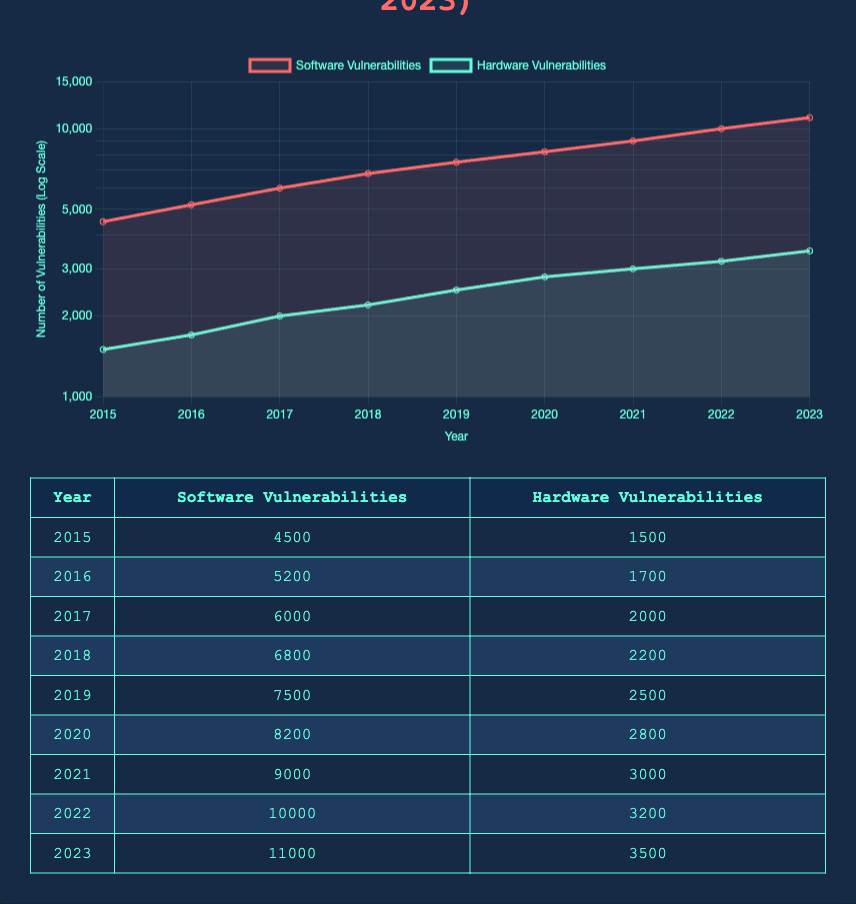What year had the highest number of software vulnerabilities disclosed? By reviewing the table, I see that the number of software vulnerabilities disclosed increases each year, reaching its peak in 2023 with 11000 disclosures.
Answer: 2023 How many hardware vulnerabilities were disclosed in 2019? The table shows that in the year 2019, there were 2500 hardware vulnerabilities disclosed.
Answer: 2500 What is the total number of software vulnerabilities disclosed from 2015 to 2018? To find the total, I add the software vulnerabilities disclosed for each year from 2015 (4500), 2016 (5200), 2017 (6000), and 2018 (6800): 4500 + 5200 + 6000 + 6800 = 22500.
Answer: 22500 Did the number of hardware vulnerabilities disclosed ever decrease during the years 2015 to 2023? I can confirm by looking at the table that the number of hardware vulnerabilities disclosed has consistently increased each year from 2015 (1500) to 2023 (3500), thus there was never a decrease.
Answer: No What is the average number of hardware vulnerabilities disclosed per year from 2020 to 2023? I will add the hardware vulnerabilities disclosed for each year from 2020 (2800), 2021 (3000), 2022 (3200), and 2023 (3500): 2800 + 3000 + 3200 + 3500 = 12500. There are 4 years, so I divide 12500 by 4 to get the average: 12500 / 4 = 3125.
Answer: 3125 Which year showed the largest increase in software vulnerabilities from the previous year? I will calculate the difference in the number of software vulnerabilities disclosed from one year to the next: 2015 to 2016 (5200 - 4500 = 700), 2016 to 2017 (6000 - 5200 = 800), and so on. The largest increase is from 2021 to 2022 (10000 - 9000 = 1000).
Answer: 2021 to 2022 What was the total number of vulnerabilities (both software and hardware) disclosed in 2021? From the table, I see that in 2021, there were 9000 software vulnerabilities and 3000 hardware vulnerabilities disclosed. Adding these together gives 9000 + 3000 = 12000 total vulnerabilities.
Answer: 12000 In how many years were more than 2000 hardware vulnerabilities disclosed? By examining the table, I can see that hardware vulnerabilities were above 2000 every year from 2017 to 2023, which totals to 7 years: 2017, 2018, 2019, 2020, 2021, 2022, and 2023.
Answer: 7 What was the percentage increase in software vulnerabilities from 2015 to 2023? To calculate the percentage increase, I take the difference between the 2023 and 2015 software vulnerabilities: (11000 - 4500) = 6500. Then I divide the difference by the original amount (4500) and multiply by 100 to get the percentage: (6500 / 4500) * 100 ≈ 144.44%.
Answer: 144.44% 